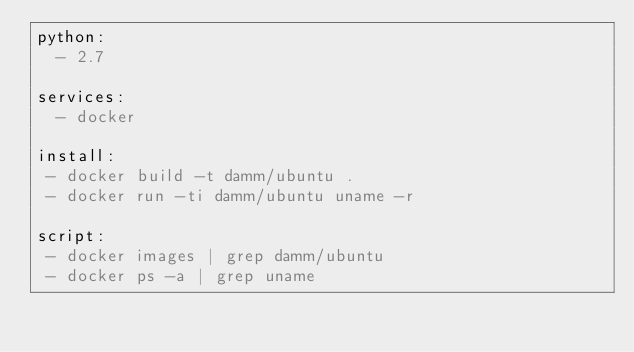Convert code to text. <code><loc_0><loc_0><loc_500><loc_500><_YAML_>python:
  - 2.7

services:
  - docker

install:
 - docker build -t damm/ubuntu .
 - docker run -ti damm/ubuntu uname -r

script:
 - docker images | grep damm/ubuntu
 - docker ps -a | grep uname</code> 